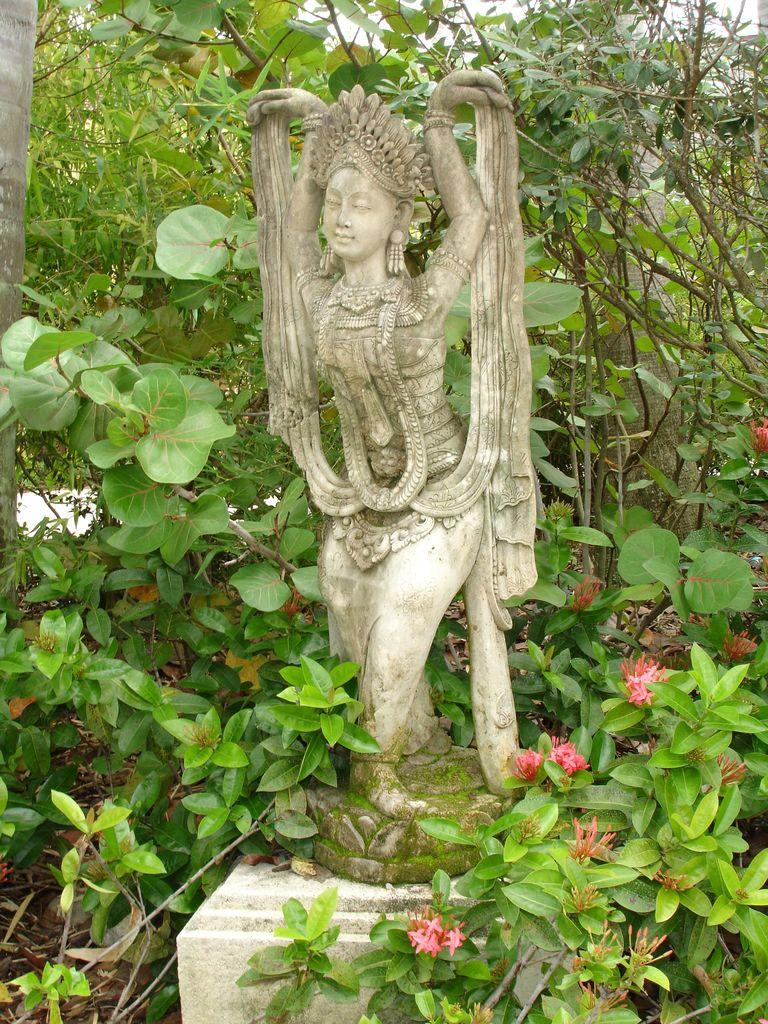What types of vegetation are present at the bottom of the image? There are flowers and plants at the bottom of the image. What is the main object in the middle of the image? There is a statue in the middle of the image. What can be seen at the back side of the image? There are trees at the back side of the image. What color is the crayon used to draw the statue in the image? There is no crayon present in the image; it is a photograph or illustration of a statue. Can you tell me the name of the person who suggested the statue's design? There is no information about the statue's designer or any suggestions in the image. 